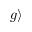Convert formula to latex. <formula><loc_0><loc_0><loc_500><loc_500>| g \rangle</formula> 